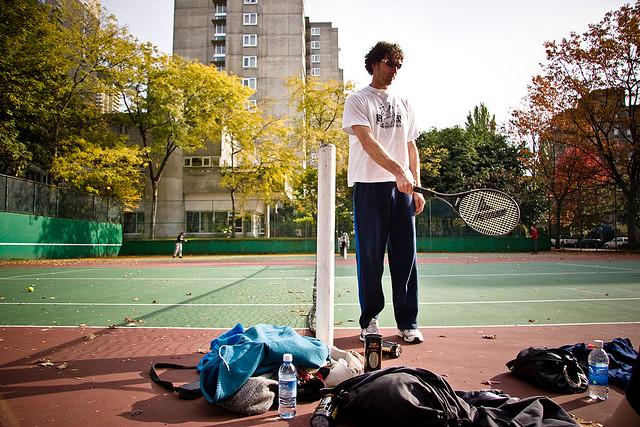What is the man holding?
Write a very short answer. Tennis racket. What color is the pitch?
Give a very brief answer. Green. How many bottles of water are in the picture?
Short answer required. 2. 